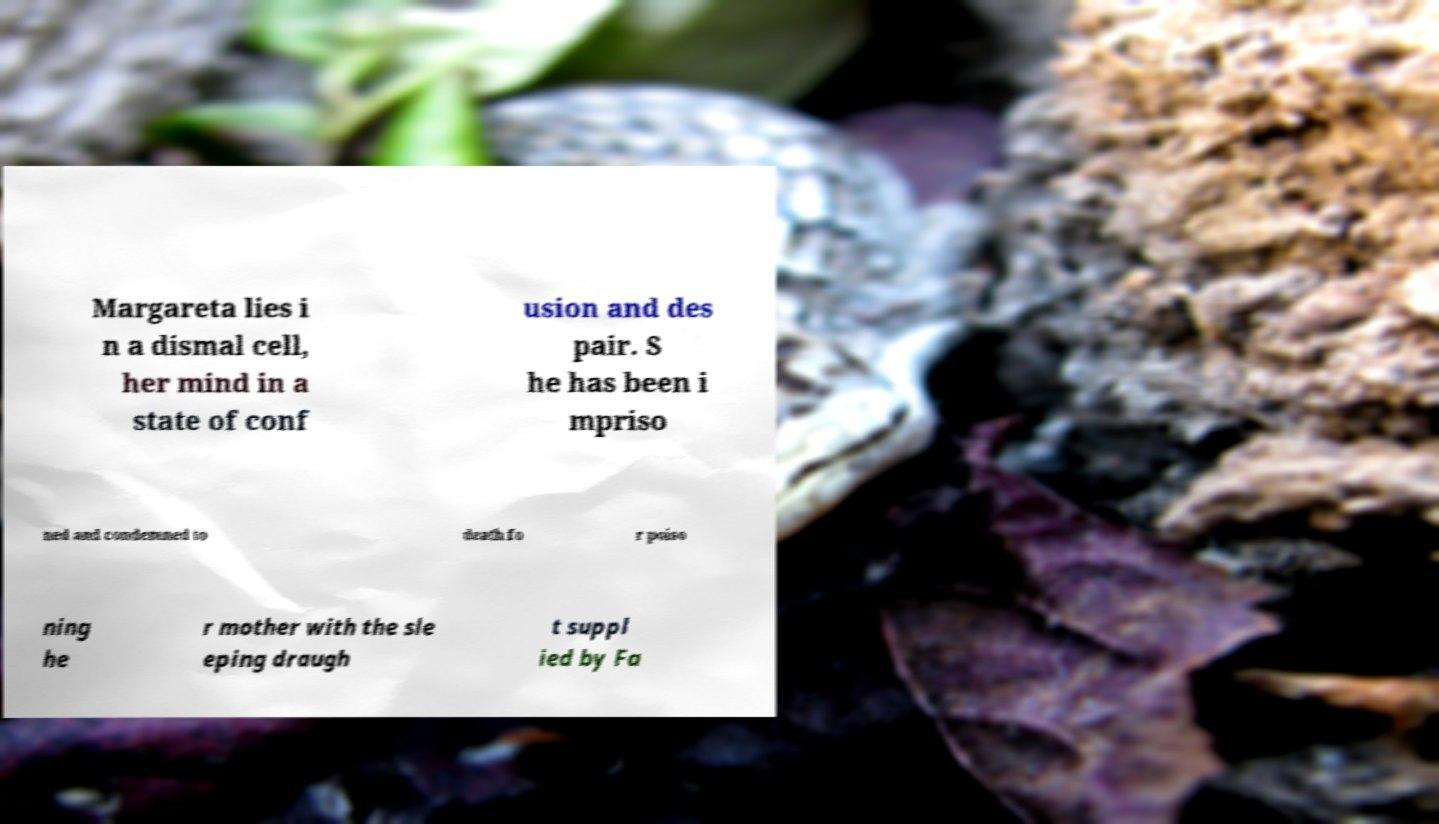Can you accurately transcribe the text from the provided image for me? Margareta lies i n a dismal cell, her mind in a state of conf usion and des pair. S he has been i mpriso ned and condemned to death fo r poiso ning he r mother with the sle eping draugh t suppl ied by Fa 